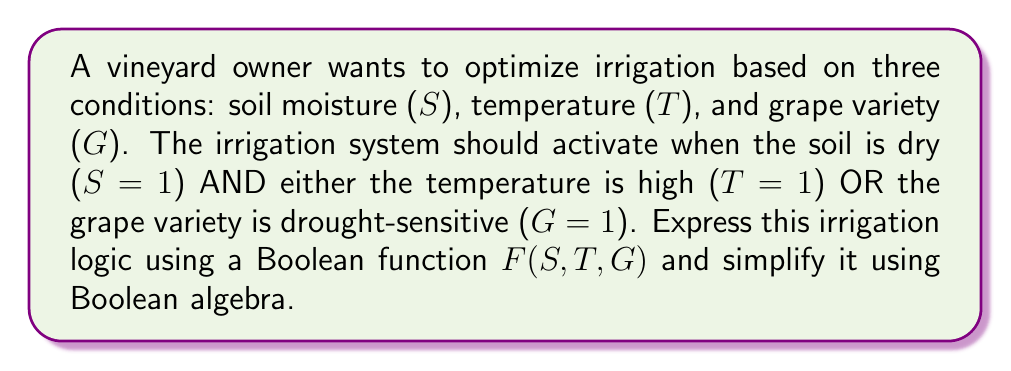Can you answer this question? Let's approach this step-by-step:

1) First, we need to express the irrigation logic as a Boolean function:
   F(S, T, G) = S AND (T OR G)

2) In Boolean algebra notation, this can be written as:
   $$F(S, T, G) = S \cdot (T + G)$$

3) This expression is already in its simplest form, known as the Sum of Products (SOP) form. However, let's verify using Boolean algebra laws:

   a) Using the distributive law: A(B + C) = AB + AC
      $$S \cdot (T + G) = S \cdot T + S \cdot G$$

   b) This expanded form is equivalent to our original expression, confirming it's already simplified.

4) To interpret this function:
   - F = 1 (irrigation on) when S = 1 AND (T = 1 OR G = 1)
   - F = 0 (irrigation off) in all other cases

5) The truth table for this function would be:

   | S | T | G | F |
   |---|---|---|---|
   | 0 | 0 | 0 | 0 |
   | 0 | 0 | 1 | 0 |
   | 0 | 1 | 0 | 0 |
   | 0 | 1 | 1 | 0 |
   | 1 | 0 | 0 | 0 |
   | 1 | 0 | 1 | 1 |
   | 1 | 1 | 0 | 1 |
   | 1 | 1 | 1 | 1 |

This Boolean function effectively represents the vineyard owner's irrigation logic, activating the system when the soil is dry and either the temperature is high or the grape variety is drought-sensitive.
Answer: $$F(S, T, G) = S \cdot (T + G)$$ 